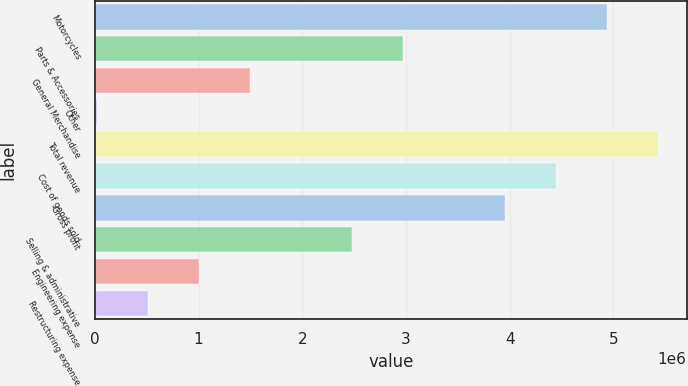<chart> <loc_0><loc_0><loc_500><loc_500><bar_chart><fcel>Motorcycles<fcel>Parts & Accessories<fcel>General Merchandise<fcel>Other<fcel>Total revenue<fcel>Cost of goods sold<fcel>Gross profit<fcel>Selling & administrative<fcel>Engineering expense<fcel>Restructuring expense<nl><fcel>4.94258e+06<fcel>2.97293e+06<fcel>1.49568e+06<fcel>18440<fcel>5.435e+06<fcel>4.45017e+06<fcel>3.95775e+06<fcel>2.48051e+06<fcel>1.00327e+06<fcel>510854<nl></chart> 